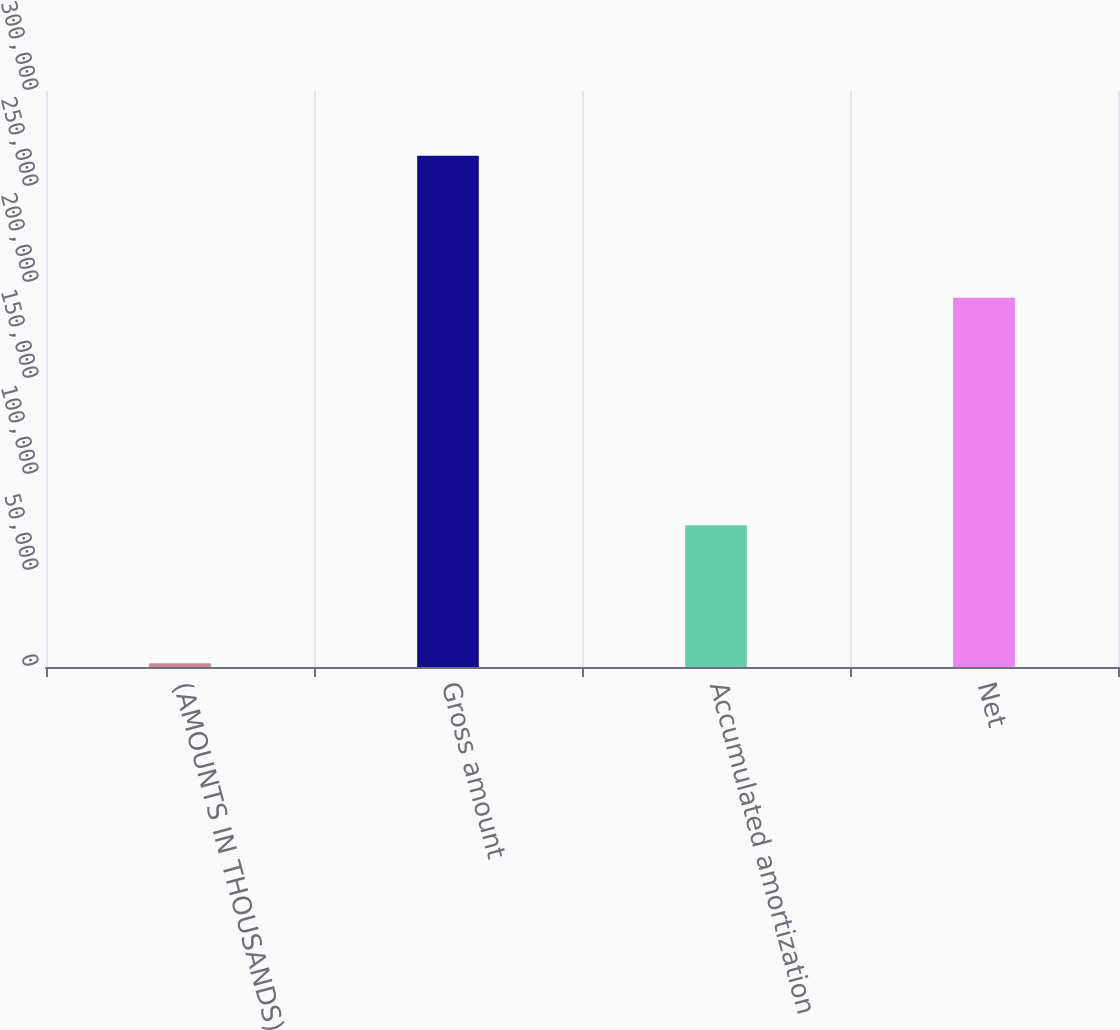Convert chart to OTSL. <chart><loc_0><loc_0><loc_500><loc_500><bar_chart><fcel>(AMOUNTS IN THOUSANDS)<fcel>Gross amount<fcel>Accumulated amortization<fcel>Net<nl><fcel>2005<fcel>266268<fcel>73893<fcel>192375<nl></chart> 